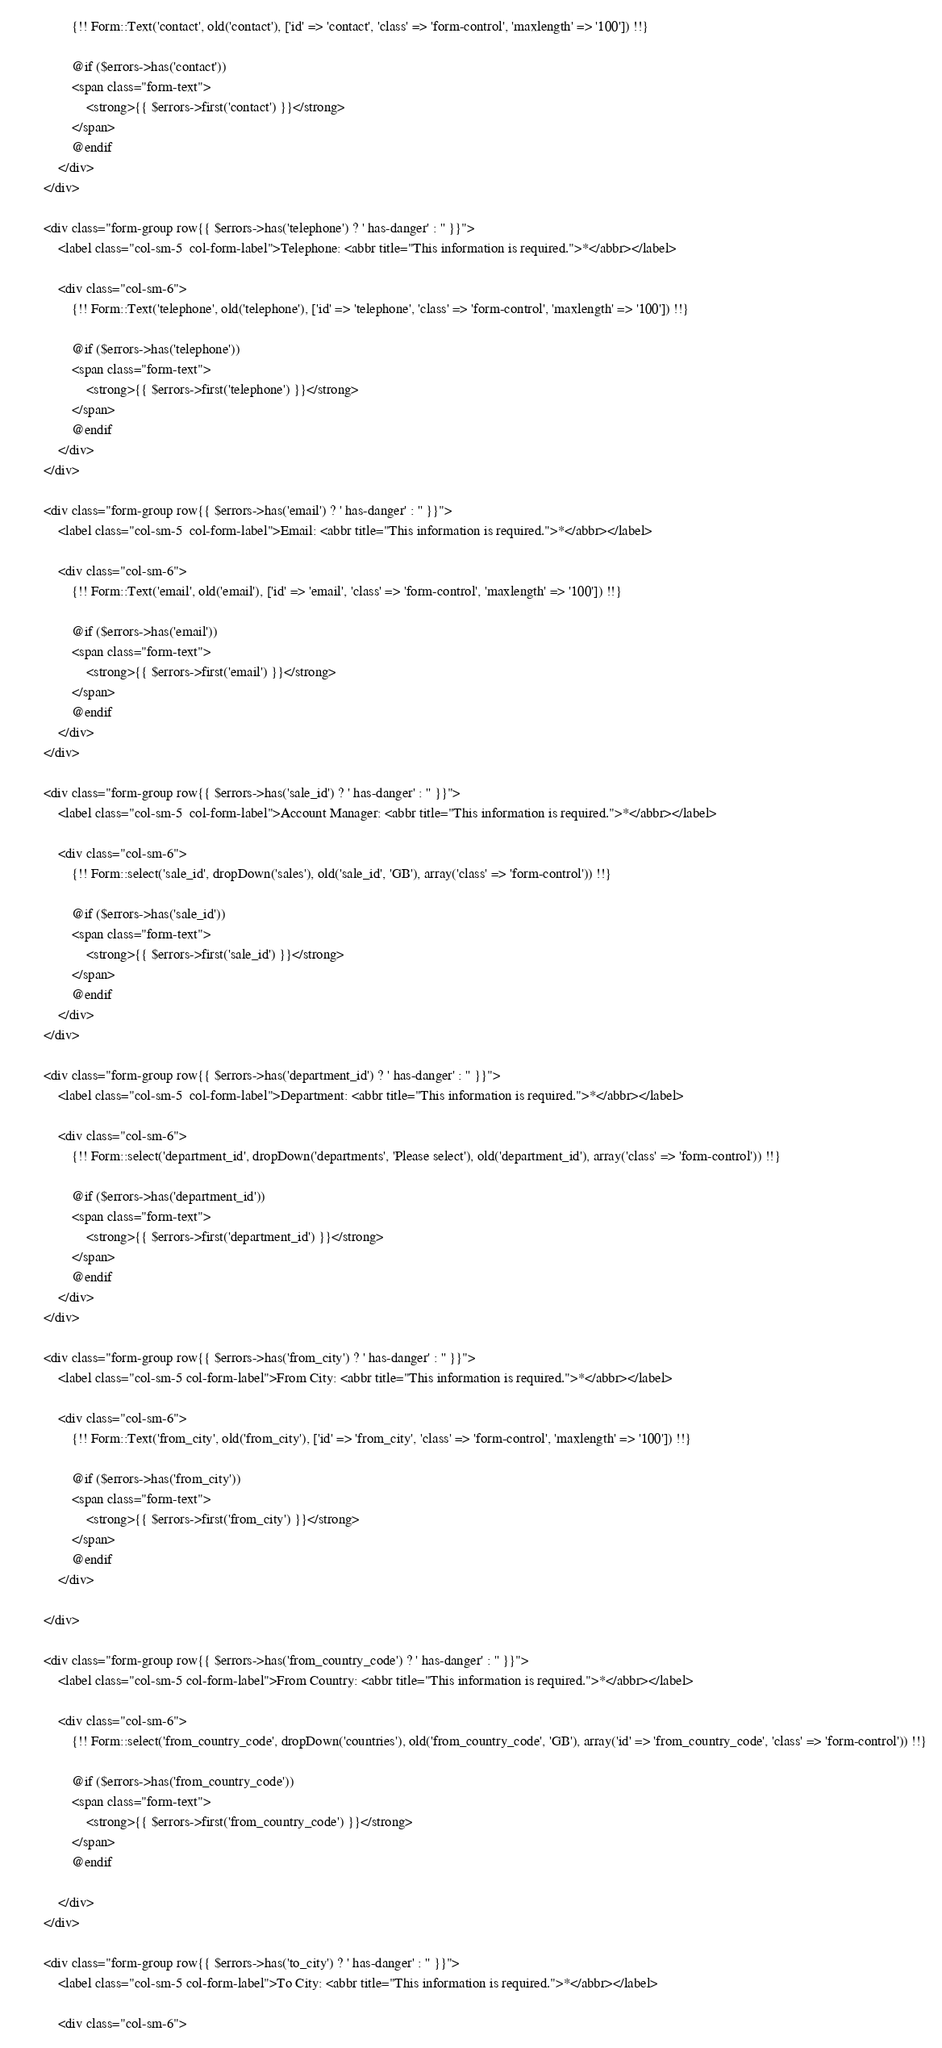Convert code to text. <code><loc_0><loc_0><loc_500><loc_500><_PHP_>                {!! Form::Text('contact', old('contact'), ['id' => 'contact', 'class' => 'form-control', 'maxlength' => '100']) !!}

                @if ($errors->has('contact'))
                <span class="form-text">
                    <strong>{{ $errors->first('contact') }}</strong>
                </span>
                @endif
            </div>
        </div>

        <div class="form-group row{{ $errors->has('telephone') ? ' has-danger' : '' }}">
            <label class="col-sm-5  col-form-label">Telephone: <abbr title="This information is required.">*</abbr></label>

            <div class="col-sm-6">
                {!! Form::Text('telephone', old('telephone'), ['id' => 'telephone', 'class' => 'form-control', 'maxlength' => '100']) !!}

                @if ($errors->has('telephone'))
                <span class="form-text">
                    <strong>{{ $errors->first('telephone') }}</strong>
                </span>
                @endif
            </div>
        </div>

        <div class="form-group row{{ $errors->has('email') ? ' has-danger' : '' }}">
            <label class="col-sm-5  col-form-label">Email: <abbr title="This information is required.">*</abbr></label>

            <div class="col-sm-6">
                {!! Form::Text('email', old('email'), ['id' => 'email', 'class' => 'form-control', 'maxlength' => '100']) !!}

                @if ($errors->has('email'))
                <span class="form-text">
                    <strong>{{ $errors->first('email') }}</strong>
                </span>
                @endif
            </div>
        </div>

        <div class="form-group row{{ $errors->has('sale_id') ? ' has-danger' : '' }}">
            <label class="col-sm-5  col-form-label">Account Manager: <abbr title="This information is required.">*</abbr></label>

            <div class="col-sm-6">
                {!! Form::select('sale_id', dropDown('sales'), old('sale_id', 'GB'), array('class' => 'form-control')) !!}

                @if ($errors->has('sale_id'))
                <span class="form-text">
                    <strong>{{ $errors->first('sale_id') }}</strong>
                </span>
                @endif
            </div>
        </div>

        <div class="form-group row{{ $errors->has('department_id') ? ' has-danger' : '' }}">
            <label class="col-sm-5  col-form-label">Department: <abbr title="This information is required.">*</abbr></label>

            <div class="col-sm-6">
                {!! Form::select('department_id', dropDown('departments', 'Please select'), old('department_id'), array('class' => 'form-control')) !!}

                @if ($errors->has('department_id'))
                <span class="form-text">
                    <strong>{{ $errors->first('department_id') }}</strong>
                </span>
                @endif
            </div>
        </div>

        <div class="form-group row{{ $errors->has('from_city') ? ' has-danger' : '' }}">
            <label class="col-sm-5 col-form-label">From City: <abbr title="This information is required.">*</abbr></label>

            <div class="col-sm-6">
                {!! Form::Text('from_city', old('from_city'), ['id' => 'from_city', 'class' => 'form-control', 'maxlength' => '100']) !!}

                @if ($errors->has('from_city'))
                <span class="form-text">
                    <strong>{{ $errors->first('from_city') }}</strong>
                </span>
                @endif
            </div>

        </div>

        <div class="form-group row{{ $errors->has('from_country_code') ? ' has-danger' : '' }}">
            <label class="col-sm-5 col-form-label">From Country: <abbr title="This information is required.">*</abbr></label>

            <div class="col-sm-6">
                {!! Form::select('from_country_code', dropDown('countries'), old('from_country_code', 'GB'), array('id' => 'from_country_code', 'class' => 'form-control')) !!}

                @if ($errors->has('from_country_code'))
                <span class="form-text">
                    <strong>{{ $errors->first('from_country_code') }}</strong>
                </span>
                @endif

            </div>
        </div>

        <div class="form-group row{{ $errors->has('to_city') ? ' has-danger' : '' }}">
            <label class="col-sm-5 col-form-label">To City: <abbr title="This information is required.">*</abbr></label>

            <div class="col-sm-6"></code> 